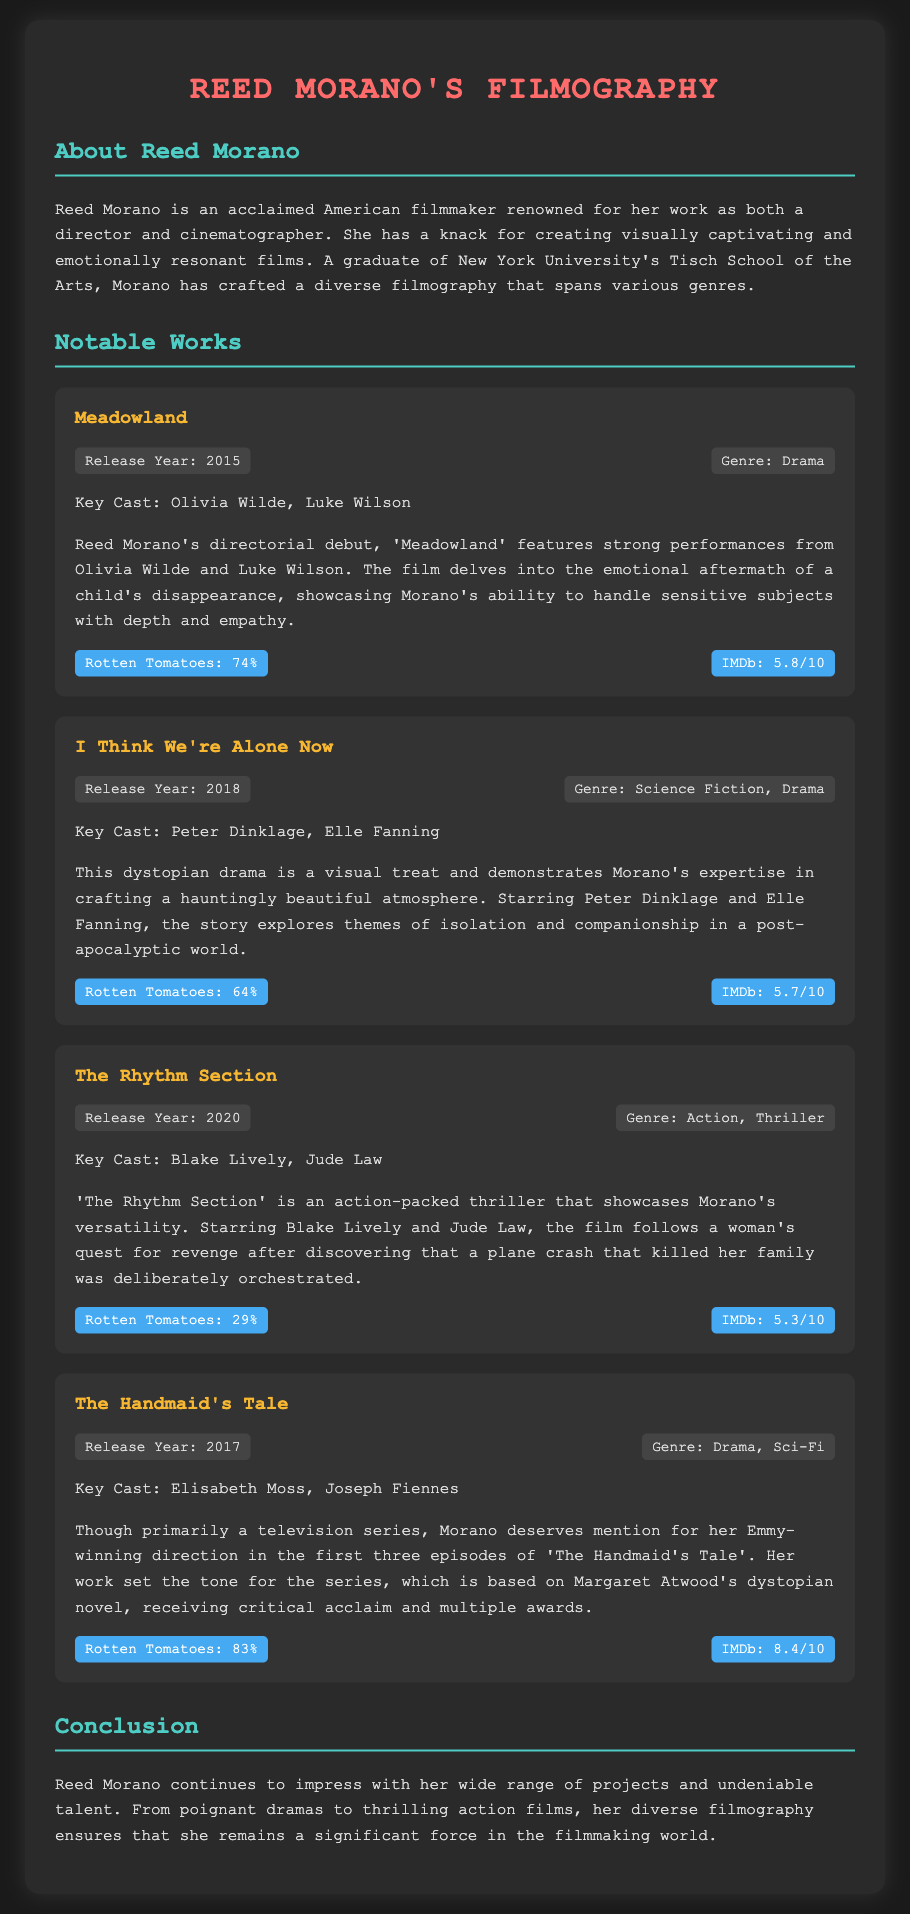what is Reed Morano's directorial debut? The document mentions that Reed Morano's directorial debut is 'Meadowland'.
Answer: Meadowland who star in 'I Think We're Alone Now'? The document lists Peter Dinklage and Elle Fanning as the key cast for 'I Think We're Alone Now'.
Answer: Peter Dinklage, Elle Fanning what genre is 'The Rhythm Section'? The film 'The Rhythm Section' is categorized as an Action, Thriller.
Answer: Action, Thriller what is the Rotten Tomatoes rating for 'The Handmaid's Tale'? The document states that 'The Handmaid's Tale' has a Rotten Tomatoes rating of 83%.
Answer: 83% which film features Olivia Wilde? The document indicates that 'Meadowland' features strong performances from Olivia Wilde.
Answer: Meadowland what year was 'The Rhythm Section' released? According to the document, 'The Rhythm Section' was released in 2020.
Answer: 2020 how many episodes did Reed Morano direct for 'The Handmaid's Tale'? The document mentions that she directed the first three episodes of 'The Handmaid's Tale'.
Answer: Three episodes which genre is most represented in Reed Morano's filmography? The document includes genres like Drama, Science Fiction, and Action, but doesn't quantify; it’s reasonable to deduce drama is prominent based on multiple entries.
Answer: Drama 